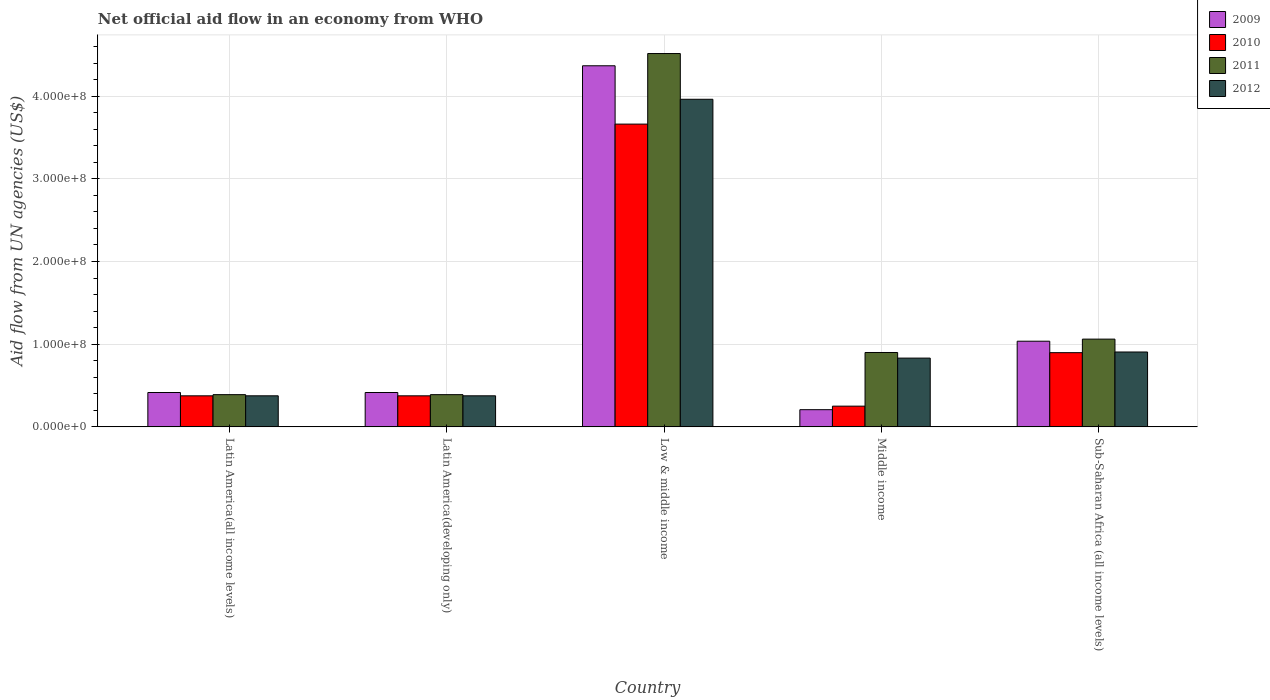How many different coloured bars are there?
Offer a very short reply. 4. How many groups of bars are there?
Your answer should be very brief. 5. Are the number of bars per tick equal to the number of legend labels?
Give a very brief answer. Yes. Are the number of bars on each tick of the X-axis equal?
Ensure brevity in your answer.  Yes. How many bars are there on the 2nd tick from the right?
Provide a succinct answer. 4. What is the label of the 3rd group of bars from the left?
Offer a very short reply. Low & middle income. In how many cases, is the number of bars for a given country not equal to the number of legend labels?
Give a very brief answer. 0. What is the net official aid flow in 2011 in Low & middle income?
Give a very brief answer. 4.52e+08. Across all countries, what is the maximum net official aid flow in 2011?
Offer a terse response. 4.52e+08. Across all countries, what is the minimum net official aid flow in 2010?
Ensure brevity in your answer.  2.51e+07. In which country was the net official aid flow in 2011 maximum?
Offer a very short reply. Low & middle income. In which country was the net official aid flow in 2012 minimum?
Offer a very short reply. Latin America(all income levels). What is the total net official aid flow in 2009 in the graph?
Ensure brevity in your answer.  6.44e+08. What is the difference between the net official aid flow in 2010 in Latin America(all income levels) and that in Latin America(developing only)?
Offer a very short reply. 0. What is the difference between the net official aid flow in 2012 in Middle income and the net official aid flow in 2011 in Low & middle income?
Keep it short and to the point. -3.68e+08. What is the average net official aid flow in 2010 per country?
Make the answer very short. 1.11e+08. What is the difference between the net official aid flow of/in 2009 and net official aid flow of/in 2010 in Low & middle income?
Make the answer very short. 7.06e+07. What is the ratio of the net official aid flow in 2009 in Latin America(all income levels) to that in Middle income?
Keep it short and to the point. 2. What is the difference between the highest and the second highest net official aid flow in 2012?
Your answer should be compact. 3.06e+08. What is the difference between the highest and the lowest net official aid flow in 2011?
Provide a short and direct response. 4.13e+08. In how many countries, is the net official aid flow in 2012 greater than the average net official aid flow in 2012 taken over all countries?
Make the answer very short. 1. Is the sum of the net official aid flow in 2010 in Latin America(all income levels) and Middle income greater than the maximum net official aid flow in 2011 across all countries?
Make the answer very short. No. Is it the case that in every country, the sum of the net official aid flow in 2012 and net official aid flow in 2011 is greater than the sum of net official aid flow in 2009 and net official aid flow in 2010?
Provide a short and direct response. No. What does the 4th bar from the right in Middle income represents?
Make the answer very short. 2009. Are all the bars in the graph horizontal?
Your response must be concise. No. How many countries are there in the graph?
Offer a very short reply. 5. What is the difference between two consecutive major ticks on the Y-axis?
Provide a succinct answer. 1.00e+08. Are the values on the major ticks of Y-axis written in scientific E-notation?
Your response must be concise. Yes. Does the graph contain grids?
Provide a short and direct response. Yes. Where does the legend appear in the graph?
Your response must be concise. Top right. What is the title of the graph?
Make the answer very short. Net official aid flow in an economy from WHO. Does "1999" appear as one of the legend labels in the graph?
Your response must be concise. No. What is the label or title of the X-axis?
Offer a very short reply. Country. What is the label or title of the Y-axis?
Offer a terse response. Aid flow from UN agencies (US$). What is the Aid flow from UN agencies (US$) in 2009 in Latin America(all income levels)?
Ensure brevity in your answer.  4.16e+07. What is the Aid flow from UN agencies (US$) of 2010 in Latin America(all income levels)?
Offer a terse response. 3.76e+07. What is the Aid flow from UN agencies (US$) in 2011 in Latin America(all income levels)?
Offer a very short reply. 3.90e+07. What is the Aid flow from UN agencies (US$) in 2012 in Latin America(all income levels)?
Keep it short and to the point. 3.76e+07. What is the Aid flow from UN agencies (US$) in 2009 in Latin America(developing only)?
Your response must be concise. 4.16e+07. What is the Aid flow from UN agencies (US$) of 2010 in Latin America(developing only)?
Provide a short and direct response. 3.76e+07. What is the Aid flow from UN agencies (US$) of 2011 in Latin America(developing only)?
Give a very brief answer. 3.90e+07. What is the Aid flow from UN agencies (US$) in 2012 in Latin America(developing only)?
Your response must be concise. 3.76e+07. What is the Aid flow from UN agencies (US$) in 2009 in Low & middle income?
Provide a succinct answer. 4.37e+08. What is the Aid flow from UN agencies (US$) of 2010 in Low & middle income?
Your response must be concise. 3.66e+08. What is the Aid flow from UN agencies (US$) of 2011 in Low & middle income?
Your answer should be very brief. 4.52e+08. What is the Aid flow from UN agencies (US$) in 2012 in Low & middle income?
Provide a short and direct response. 3.96e+08. What is the Aid flow from UN agencies (US$) of 2009 in Middle income?
Make the answer very short. 2.08e+07. What is the Aid flow from UN agencies (US$) in 2010 in Middle income?
Offer a very short reply. 2.51e+07. What is the Aid flow from UN agencies (US$) of 2011 in Middle income?
Your response must be concise. 9.00e+07. What is the Aid flow from UN agencies (US$) of 2012 in Middle income?
Your answer should be compact. 8.32e+07. What is the Aid flow from UN agencies (US$) in 2009 in Sub-Saharan Africa (all income levels)?
Offer a terse response. 1.04e+08. What is the Aid flow from UN agencies (US$) in 2010 in Sub-Saharan Africa (all income levels)?
Provide a succinct answer. 8.98e+07. What is the Aid flow from UN agencies (US$) of 2011 in Sub-Saharan Africa (all income levels)?
Give a very brief answer. 1.06e+08. What is the Aid flow from UN agencies (US$) in 2012 in Sub-Saharan Africa (all income levels)?
Give a very brief answer. 9.06e+07. Across all countries, what is the maximum Aid flow from UN agencies (US$) of 2009?
Provide a succinct answer. 4.37e+08. Across all countries, what is the maximum Aid flow from UN agencies (US$) of 2010?
Ensure brevity in your answer.  3.66e+08. Across all countries, what is the maximum Aid flow from UN agencies (US$) of 2011?
Your response must be concise. 4.52e+08. Across all countries, what is the maximum Aid flow from UN agencies (US$) in 2012?
Keep it short and to the point. 3.96e+08. Across all countries, what is the minimum Aid flow from UN agencies (US$) in 2009?
Your response must be concise. 2.08e+07. Across all countries, what is the minimum Aid flow from UN agencies (US$) of 2010?
Provide a succinct answer. 2.51e+07. Across all countries, what is the minimum Aid flow from UN agencies (US$) in 2011?
Your answer should be very brief. 3.90e+07. Across all countries, what is the minimum Aid flow from UN agencies (US$) in 2012?
Provide a succinct answer. 3.76e+07. What is the total Aid flow from UN agencies (US$) of 2009 in the graph?
Give a very brief answer. 6.44e+08. What is the total Aid flow from UN agencies (US$) in 2010 in the graph?
Provide a short and direct response. 5.56e+08. What is the total Aid flow from UN agencies (US$) in 2011 in the graph?
Your answer should be very brief. 7.26e+08. What is the total Aid flow from UN agencies (US$) in 2012 in the graph?
Make the answer very short. 6.45e+08. What is the difference between the Aid flow from UN agencies (US$) of 2011 in Latin America(all income levels) and that in Latin America(developing only)?
Ensure brevity in your answer.  0. What is the difference between the Aid flow from UN agencies (US$) of 2012 in Latin America(all income levels) and that in Latin America(developing only)?
Your answer should be very brief. 0. What is the difference between the Aid flow from UN agencies (US$) in 2009 in Latin America(all income levels) and that in Low & middle income?
Offer a very short reply. -3.95e+08. What is the difference between the Aid flow from UN agencies (US$) in 2010 in Latin America(all income levels) and that in Low & middle income?
Keep it short and to the point. -3.29e+08. What is the difference between the Aid flow from UN agencies (US$) in 2011 in Latin America(all income levels) and that in Low & middle income?
Provide a short and direct response. -4.13e+08. What is the difference between the Aid flow from UN agencies (US$) in 2012 in Latin America(all income levels) and that in Low & middle income?
Provide a succinct answer. -3.59e+08. What is the difference between the Aid flow from UN agencies (US$) of 2009 in Latin America(all income levels) and that in Middle income?
Ensure brevity in your answer.  2.08e+07. What is the difference between the Aid flow from UN agencies (US$) in 2010 in Latin America(all income levels) and that in Middle income?
Make the answer very short. 1.25e+07. What is the difference between the Aid flow from UN agencies (US$) in 2011 in Latin America(all income levels) and that in Middle income?
Offer a terse response. -5.10e+07. What is the difference between the Aid flow from UN agencies (US$) of 2012 in Latin America(all income levels) and that in Middle income?
Provide a succinct answer. -4.56e+07. What is the difference between the Aid flow from UN agencies (US$) in 2009 in Latin America(all income levels) and that in Sub-Saharan Africa (all income levels)?
Provide a short and direct response. -6.20e+07. What is the difference between the Aid flow from UN agencies (US$) in 2010 in Latin America(all income levels) and that in Sub-Saharan Africa (all income levels)?
Your answer should be very brief. -5.22e+07. What is the difference between the Aid flow from UN agencies (US$) in 2011 in Latin America(all income levels) and that in Sub-Saharan Africa (all income levels)?
Keep it short and to the point. -6.72e+07. What is the difference between the Aid flow from UN agencies (US$) of 2012 in Latin America(all income levels) and that in Sub-Saharan Africa (all income levels)?
Your answer should be very brief. -5.30e+07. What is the difference between the Aid flow from UN agencies (US$) of 2009 in Latin America(developing only) and that in Low & middle income?
Provide a short and direct response. -3.95e+08. What is the difference between the Aid flow from UN agencies (US$) in 2010 in Latin America(developing only) and that in Low & middle income?
Your response must be concise. -3.29e+08. What is the difference between the Aid flow from UN agencies (US$) of 2011 in Latin America(developing only) and that in Low & middle income?
Your answer should be compact. -4.13e+08. What is the difference between the Aid flow from UN agencies (US$) in 2012 in Latin America(developing only) and that in Low & middle income?
Your answer should be compact. -3.59e+08. What is the difference between the Aid flow from UN agencies (US$) in 2009 in Latin America(developing only) and that in Middle income?
Your answer should be compact. 2.08e+07. What is the difference between the Aid flow from UN agencies (US$) in 2010 in Latin America(developing only) and that in Middle income?
Your response must be concise. 1.25e+07. What is the difference between the Aid flow from UN agencies (US$) in 2011 in Latin America(developing only) and that in Middle income?
Keep it short and to the point. -5.10e+07. What is the difference between the Aid flow from UN agencies (US$) in 2012 in Latin America(developing only) and that in Middle income?
Offer a terse response. -4.56e+07. What is the difference between the Aid flow from UN agencies (US$) of 2009 in Latin America(developing only) and that in Sub-Saharan Africa (all income levels)?
Your response must be concise. -6.20e+07. What is the difference between the Aid flow from UN agencies (US$) of 2010 in Latin America(developing only) and that in Sub-Saharan Africa (all income levels)?
Ensure brevity in your answer.  -5.22e+07. What is the difference between the Aid flow from UN agencies (US$) in 2011 in Latin America(developing only) and that in Sub-Saharan Africa (all income levels)?
Provide a succinct answer. -6.72e+07. What is the difference between the Aid flow from UN agencies (US$) in 2012 in Latin America(developing only) and that in Sub-Saharan Africa (all income levels)?
Make the answer very short. -5.30e+07. What is the difference between the Aid flow from UN agencies (US$) in 2009 in Low & middle income and that in Middle income?
Your response must be concise. 4.16e+08. What is the difference between the Aid flow from UN agencies (US$) in 2010 in Low & middle income and that in Middle income?
Offer a terse response. 3.41e+08. What is the difference between the Aid flow from UN agencies (US$) of 2011 in Low & middle income and that in Middle income?
Give a very brief answer. 3.62e+08. What is the difference between the Aid flow from UN agencies (US$) in 2012 in Low & middle income and that in Middle income?
Your response must be concise. 3.13e+08. What is the difference between the Aid flow from UN agencies (US$) in 2009 in Low & middle income and that in Sub-Saharan Africa (all income levels)?
Provide a succinct answer. 3.33e+08. What is the difference between the Aid flow from UN agencies (US$) in 2010 in Low & middle income and that in Sub-Saharan Africa (all income levels)?
Provide a short and direct response. 2.76e+08. What is the difference between the Aid flow from UN agencies (US$) of 2011 in Low & middle income and that in Sub-Saharan Africa (all income levels)?
Give a very brief answer. 3.45e+08. What is the difference between the Aid flow from UN agencies (US$) in 2012 in Low & middle income and that in Sub-Saharan Africa (all income levels)?
Your response must be concise. 3.06e+08. What is the difference between the Aid flow from UN agencies (US$) of 2009 in Middle income and that in Sub-Saharan Africa (all income levels)?
Your answer should be compact. -8.28e+07. What is the difference between the Aid flow from UN agencies (US$) of 2010 in Middle income and that in Sub-Saharan Africa (all income levels)?
Your answer should be compact. -6.47e+07. What is the difference between the Aid flow from UN agencies (US$) of 2011 in Middle income and that in Sub-Saharan Africa (all income levels)?
Your response must be concise. -1.62e+07. What is the difference between the Aid flow from UN agencies (US$) of 2012 in Middle income and that in Sub-Saharan Africa (all income levels)?
Your answer should be compact. -7.39e+06. What is the difference between the Aid flow from UN agencies (US$) in 2009 in Latin America(all income levels) and the Aid flow from UN agencies (US$) in 2010 in Latin America(developing only)?
Give a very brief answer. 4.01e+06. What is the difference between the Aid flow from UN agencies (US$) of 2009 in Latin America(all income levels) and the Aid flow from UN agencies (US$) of 2011 in Latin America(developing only)?
Offer a terse response. 2.59e+06. What is the difference between the Aid flow from UN agencies (US$) of 2009 in Latin America(all income levels) and the Aid flow from UN agencies (US$) of 2012 in Latin America(developing only)?
Provide a succinct answer. 3.99e+06. What is the difference between the Aid flow from UN agencies (US$) of 2010 in Latin America(all income levels) and the Aid flow from UN agencies (US$) of 2011 in Latin America(developing only)?
Ensure brevity in your answer.  -1.42e+06. What is the difference between the Aid flow from UN agencies (US$) in 2011 in Latin America(all income levels) and the Aid flow from UN agencies (US$) in 2012 in Latin America(developing only)?
Make the answer very short. 1.40e+06. What is the difference between the Aid flow from UN agencies (US$) in 2009 in Latin America(all income levels) and the Aid flow from UN agencies (US$) in 2010 in Low & middle income?
Your response must be concise. -3.25e+08. What is the difference between the Aid flow from UN agencies (US$) in 2009 in Latin America(all income levels) and the Aid flow from UN agencies (US$) in 2011 in Low & middle income?
Provide a short and direct response. -4.10e+08. What is the difference between the Aid flow from UN agencies (US$) of 2009 in Latin America(all income levels) and the Aid flow from UN agencies (US$) of 2012 in Low & middle income?
Ensure brevity in your answer.  -3.55e+08. What is the difference between the Aid flow from UN agencies (US$) in 2010 in Latin America(all income levels) and the Aid flow from UN agencies (US$) in 2011 in Low & middle income?
Your answer should be compact. -4.14e+08. What is the difference between the Aid flow from UN agencies (US$) of 2010 in Latin America(all income levels) and the Aid flow from UN agencies (US$) of 2012 in Low & middle income?
Keep it short and to the point. -3.59e+08. What is the difference between the Aid flow from UN agencies (US$) of 2011 in Latin America(all income levels) and the Aid flow from UN agencies (US$) of 2012 in Low & middle income?
Offer a terse response. -3.57e+08. What is the difference between the Aid flow from UN agencies (US$) of 2009 in Latin America(all income levels) and the Aid flow from UN agencies (US$) of 2010 in Middle income?
Provide a succinct answer. 1.65e+07. What is the difference between the Aid flow from UN agencies (US$) of 2009 in Latin America(all income levels) and the Aid flow from UN agencies (US$) of 2011 in Middle income?
Provide a succinct answer. -4.84e+07. What is the difference between the Aid flow from UN agencies (US$) of 2009 in Latin America(all income levels) and the Aid flow from UN agencies (US$) of 2012 in Middle income?
Ensure brevity in your answer.  -4.16e+07. What is the difference between the Aid flow from UN agencies (US$) in 2010 in Latin America(all income levels) and the Aid flow from UN agencies (US$) in 2011 in Middle income?
Your answer should be compact. -5.24e+07. What is the difference between the Aid flow from UN agencies (US$) of 2010 in Latin America(all income levels) and the Aid flow from UN agencies (US$) of 2012 in Middle income?
Offer a terse response. -4.56e+07. What is the difference between the Aid flow from UN agencies (US$) of 2011 in Latin America(all income levels) and the Aid flow from UN agencies (US$) of 2012 in Middle income?
Your answer should be compact. -4.42e+07. What is the difference between the Aid flow from UN agencies (US$) of 2009 in Latin America(all income levels) and the Aid flow from UN agencies (US$) of 2010 in Sub-Saharan Africa (all income levels)?
Your answer should be compact. -4.82e+07. What is the difference between the Aid flow from UN agencies (US$) in 2009 in Latin America(all income levels) and the Aid flow from UN agencies (US$) in 2011 in Sub-Saharan Africa (all income levels)?
Make the answer very short. -6.46e+07. What is the difference between the Aid flow from UN agencies (US$) of 2009 in Latin America(all income levels) and the Aid flow from UN agencies (US$) of 2012 in Sub-Saharan Africa (all income levels)?
Provide a short and direct response. -4.90e+07. What is the difference between the Aid flow from UN agencies (US$) in 2010 in Latin America(all income levels) and the Aid flow from UN agencies (US$) in 2011 in Sub-Saharan Africa (all income levels)?
Make the answer very short. -6.86e+07. What is the difference between the Aid flow from UN agencies (US$) in 2010 in Latin America(all income levels) and the Aid flow from UN agencies (US$) in 2012 in Sub-Saharan Africa (all income levels)?
Give a very brief answer. -5.30e+07. What is the difference between the Aid flow from UN agencies (US$) in 2011 in Latin America(all income levels) and the Aid flow from UN agencies (US$) in 2012 in Sub-Saharan Africa (all income levels)?
Offer a terse response. -5.16e+07. What is the difference between the Aid flow from UN agencies (US$) of 2009 in Latin America(developing only) and the Aid flow from UN agencies (US$) of 2010 in Low & middle income?
Keep it short and to the point. -3.25e+08. What is the difference between the Aid flow from UN agencies (US$) of 2009 in Latin America(developing only) and the Aid flow from UN agencies (US$) of 2011 in Low & middle income?
Give a very brief answer. -4.10e+08. What is the difference between the Aid flow from UN agencies (US$) in 2009 in Latin America(developing only) and the Aid flow from UN agencies (US$) in 2012 in Low & middle income?
Provide a succinct answer. -3.55e+08. What is the difference between the Aid flow from UN agencies (US$) of 2010 in Latin America(developing only) and the Aid flow from UN agencies (US$) of 2011 in Low & middle income?
Your answer should be very brief. -4.14e+08. What is the difference between the Aid flow from UN agencies (US$) in 2010 in Latin America(developing only) and the Aid flow from UN agencies (US$) in 2012 in Low & middle income?
Provide a short and direct response. -3.59e+08. What is the difference between the Aid flow from UN agencies (US$) of 2011 in Latin America(developing only) and the Aid flow from UN agencies (US$) of 2012 in Low & middle income?
Offer a terse response. -3.57e+08. What is the difference between the Aid flow from UN agencies (US$) of 2009 in Latin America(developing only) and the Aid flow from UN agencies (US$) of 2010 in Middle income?
Your answer should be compact. 1.65e+07. What is the difference between the Aid flow from UN agencies (US$) in 2009 in Latin America(developing only) and the Aid flow from UN agencies (US$) in 2011 in Middle income?
Provide a succinct answer. -4.84e+07. What is the difference between the Aid flow from UN agencies (US$) of 2009 in Latin America(developing only) and the Aid flow from UN agencies (US$) of 2012 in Middle income?
Offer a terse response. -4.16e+07. What is the difference between the Aid flow from UN agencies (US$) of 2010 in Latin America(developing only) and the Aid flow from UN agencies (US$) of 2011 in Middle income?
Offer a very short reply. -5.24e+07. What is the difference between the Aid flow from UN agencies (US$) of 2010 in Latin America(developing only) and the Aid flow from UN agencies (US$) of 2012 in Middle income?
Your answer should be compact. -4.56e+07. What is the difference between the Aid flow from UN agencies (US$) of 2011 in Latin America(developing only) and the Aid flow from UN agencies (US$) of 2012 in Middle income?
Your answer should be very brief. -4.42e+07. What is the difference between the Aid flow from UN agencies (US$) of 2009 in Latin America(developing only) and the Aid flow from UN agencies (US$) of 2010 in Sub-Saharan Africa (all income levels)?
Provide a succinct answer. -4.82e+07. What is the difference between the Aid flow from UN agencies (US$) in 2009 in Latin America(developing only) and the Aid flow from UN agencies (US$) in 2011 in Sub-Saharan Africa (all income levels)?
Ensure brevity in your answer.  -6.46e+07. What is the difference between the Aid flow from UN agencies (US$) of 2009 in Latin America(developing only) and the Aid flow from UN agencies (US$) of 2012 in Sub-Saharan Africa (all income levels)?
Keep it short and to the point. -4.90e+07. What is the difference between the Aid flow from UN agencies (US$) of 2010 in Latin America(developing only) and the Aid flow from UN agencies (US$) of 2011 in Sub-Saharan Africa (all income levels)?
Make the answer very short. -6.86e+07. What is the difference between the Aid flow from UN agencies (US$) of 2010 in Latin America(developing only) and the Aid flow from UN agencies (US$) of 2012 in Sub-Saharan Africa (all income levels)?
Give a very brief answer. -5.30e+07. What is the difference between the Aid flow from UN agencies (US$) of 2011 in Latin America(developing only) and the Aid flow from UN agencies (US$) of 2012 in Sub-Saharan Africa (all income levels)?
Provide a short and direct response. -5.16e+07. What is the difference between the Aid flow from UN agencies (US$) of 2009 in Low & middle income and the Aid flow from UN agencies (US$) of 2010 in Middle income?
Provide a succinct answer. 4.12e+08. What is the difference between the Aid flow from UN agencies (US$) in 2009 in Low & middle income and the Aid flow from UN agencies (US$) in 2011 in Middle income?
Keep it short and to the point. 3.47e+08. What is the difference between the Aid flow from UN agencies (US$) in 2009 in Low & middle income and the Aid flow from UN agencies (US$) in 2012 in Middle income?
Offer a very short reply. 3.54e+08. What is the difference between the Aid flow from UN agencies (US$) in 2010 in Low & middle income and the Aid flow from UN agencies (US$) in 2011 in Middle income?
Offer a terse response. 2.76e+08. What is the difference between the Aid flow from UN agencies (US$) in 2010 in Low & middle income and the Aid flow from UN agencies (US$) in 2012 in Middle income?
Your response must be concise. 2.83e+08. What is the difference between the Aid flow from UN agencies (US$) of 2011 in Low & middle income and the Aid flow from UN agencies (US$) of 2012 in Middle income?
Make the answer very short. 3.68e+08. What is the difference between the Aid flow from UN agencies (US$) in 2009 in Low & middle income and the Aid flow from UN agencies (US$) in 2010 in Sub-Saharan Africa (all income levels)?
Your answer should be compact. 3.47e+08. What is the difference between the Aid flow from UN agencies (US$) in 2009 in Low & middle income and the Aid flow from UN agencies (US$) in 2011 in Sub-Saharan Africa (all income levels)?
Give a very brief answer. 3.31e+08. What is the difference between the Aid flow from UN agencies (US$) in 2009 in Low & middle income and the Aid flow from UN agencies (US$) in 2012 in Sub-Saharan Africa (all income levels)?
Make the answer very short. 3.46e+08. What is the difference between the Aid flow from UN agencies (US$) in 2010 in Low & middle income and the Aid flow from UN agencies (US$) in 2011 in Sub-Saharan Africa (all income levels)?
Provide a short and direct response. 2.60e+08. What is the difference between the Aid flow from UN agencies (US$) of 2010 in Low & middle income and the Aid flow from UN agencies (US$) of 2012 in Sub-Saharan Africa (all income levels)?
Provide a short and direct response. 2.76e+08. What is the difference between the Aid flow from UN agencies (US$) in 2011 in Low & middle income and the Aid flow from UN agencies (US$) in 2012 in Sub-Saharan Africa (all income levels)?
Your answer should be compact. 3.61e+08. What is the difference between the Aid flow from UN agencies (US$) of 2009 in Middle income and the Aid flow from UN agencies (US$) of 2010 in Sub-Saharan Africa (all income levels)?
Ensure brevity in your answer.  -6.90e+07. What is the difference between the Aid flow from UN agencies (US$) in 2009 in Middle income and the Aid flow from UN agencies (US$) in 2011 in Sub-Saharan Africa (all income levels)?
Provide a succinct answer. -8.54e+07. What is the difference between the Aid flow from UN agencies (US$) of 2009 in Middle income and the Aid flow from UN agencies (US$) of 2012 in Sub-Saharan Africa (all income levels)?
Provide a short and direct response. -6.98e+07. What is the difference between the Aid flow from UN agencies (US$) in 2010 in Middle income and the Aid flow from UN agencies (US$) in 2011 in Sub-Saharan Africa (all income levels)?
Keep it short and to the point. -8.11e+07. What is the difference between the Aid flow from UN agencies (US$) of 2010 in Middle income and the Aid flow from UN agencies (US$) of 2012 in Sub-Saharan Africa (all income levels)?
Ensure brevity in your answer.  -6.55e+07. What is the difference between the Aid flow from UN agencies (US$) in 2011 in Middle income and the Aid flow from UN agencies (US$) in 2012 in Sub-Saharan Africa (all income levels)?
Make the answer very short. -5.90e+05. What is the average Aid flow from UN agencies (US$) of 2009 per country?
Offer a terse response. 1.29e+08. What is the average Aid flow from UN agencies (US$) of 2010 per country?
Offer a very short reply. 1.11e+08. What is the average Aid flow from UN agencies (US$) in 2011 per country?
Make the answer very short. 1.45e+08. What is the average Aid flow from UN agencies (US$) in 2012 per country?
Provide a succinct answer. 1.29e+08. What is the difference between the Aid flow from UN agencies (US$) of 2009 and Aid flow from UN agencies (US$) of 2010 in Latin America(all income levels)?
Ensure brevity in your answer.  4.01e+06. What is the difference between the Aid flow from UN agencies (US$) in 2009 and Aid flow from UN agencies (US$) in 2011 in Latin America(all income levels)?
Ensure brevity in your answer.  2.59e+06. What is the difference between the Aid flow from UN agencies (US$) in 2009 and Aid flow from UN agencies (US$) in 2012 in Latin America(all income levels)?
Give a very brief answer. 3.99e+06. What is the difference between the Aid flow from UN agencies (US$) of 2010 and Aid flow from UN agencies (US$) of 2011 in Latin America(all income levels)?
Ensure brevity in your answer.  -1.42e+06. What is the difference between the Aid flow from UN agencies (US$) of 2011 and Aid flow from UN agencies (US$) of 2012 in Latin America(all income levels)?
Provide a succinct answer. 1.40e+06. What is the difference between the Aid flow from UN agencies (US$) of 2009 and Aid flow from UN agencies (US$) of 2010 in Latin America(developing only)?
Your answer should be compact. 4.01e+06. What is the difference between the Aid flow from UN agencies (US$) of 2009 and Aid flow from UN agencies (US$) of 2011 in Latin America(developing only)?
Your answer should be compact. 2.59e+06. What is the difference between the Aid flow from UN agencies (US$) in 2009 and Aid flow from UN agencies (US$) in 2012 in Latin America(developing only)?
Offer a very short reply. 3.99e+06. What is the difference between the Aid flow from UN agencies (US$) in 2010 and Aid flow from UN agencies (US$) in 2011 in Latin America(developing only)?
Make the answer very short. -1.42e+06. What is the difference between the Aid flow from UN agencies (US$) in 2010 and Aid flow from UN agencies (US$) in 2012 in Latin America(developing only)?
Your response must be concise. -2.00e+04. What is the difference between the Aid flow from UN agencies (US$) in 2011 and Aid flow from UN agencies (US$) in 2012 in Latin America(developing only)?
Your response must be concise. 1.40e+06. What is the difference between the Aid flow from UN agencies (US$) of 2009 and Aid flow from UN agencies (US$) of 2010 in Low & middle income?
Provide a short and direct response. 7.06e+07. What is the difference between the Aid flow from UN agencies (US$) in 2009 and Aid flow from UN agencies (US$) in 2011 in Low & middle income?
Provide a short and direct response. -1.48e+07. What is the difference between the Aid flow from UN agencies (US$) of 2009 and Aid flow from UN agencies (US$) of 2012 in Low & middle income?
Offer a very short reply. 4.05e+07. What is the difference between the Aid flow from UN agencies (US$) of 2010 and Aid flow from UN agencies (US$) of 2011 in Low & middle income?
Provide a short and direct response. -8.54e+07. What is the difference between the Aid flow from UN agencies (US$) of 2010 and Aid flow from UN agencies (US$) of 2012 in Low & middle income?
Make the answer very short. -3.00e+07. What is the difference between the Aid flow from UN agencies (US$) in 2011 and Aid flow from UN agencies (US$) in 2012 in Low & middle income?
Make the answer very short. 5.53e+07. What is the difference between the Aid flow from UN agencies (US$) of 2009 and Aid flow from UN agencies (US$) of 2010 in Middle income?
Your answer should be compact. -4.27e+06. What is the difference between the Aid flow from UN agencies (US$) of 2009 and Aid flow from UN agencies (US$) of 2011 in Middle income?
Offer a very short reply. -6.92e+07. What is the difference between the Aid flow from UN agencies (US$) in 2009 and Aid flow from UN agencies (US$) in 2012 in Middle income?
Offer a terse response. -6.24e+07. What is the difference between the Aid flow from UN agencies (US$) of 2010 and Aid flow from UN agencies (US$) of 2011 in Middle income?
Provide a succinct answer. -6.49e+07. What is the difference between the Aid flow from UN agencies (US$) of 2010 and Aid flow from UN agencies (US$) of 2012 in Middle income?
Give a very brief answer. -5.81e+07. What is the difference between the Aid flow from UN agencies (US$) in 2011 and Aid flow from UN agencies (US$) in 2012 in Middle income?
Your answer should be very brief. 6.80e+06. What is the difference between the Aid flow from UN agencies (US$) in 2009 and Aid flow from UN agencies (US$) in 2010 in Sub-Saharan Africa (all income levels)?
Ensure brevity in your answer.  1.39e+07. What is the difference between the Aid flow from UN agencies (US$) of 2009 and Aid flow from UN agencies (US$) of 2011 in Sub-Saharan Africa (all income levels)?
Ensure brevity in your answer.  -2.53e+06. What is the difference between the Aid flow from UN agencies (US$) in 2009 and Aid flow from UN agencies (US$) in 2012 in Sub-Saharan Africa (all income levels)?
Give a very brief answer. 1.30e+07. What is the difference between the Aid flow from UN agencies (US$) in 2010 and Aid flow from UN agencies (US$) in 2011 in Sub-Saharan Africa (all income levels)?
Give a very brief answer. -1.64e+07. What is the difference between the Aid flow from UN agencies (US$) of 2010 and Aid flow from UN agencies (US$) of 2012 in Sub-Saharan Africa (all income levels)?
Keep it short and to the point. -8.10e+05. What is the difference between the Aid flow from UN agencies (US$) of 2011 and Aid flow from UN agencies (US$) of 2012 in Sub-Saharan Africa (all income levels)?
Give a very brief answer. 1.56e+07. What is the ratio of the Aid flow from UN agencies (US$) in 2009 in Latin America(all income levels) to that in Latin America(developing only)?
Your answer should be very brief. 1. What is the ratio of the Aid flow from UN agencies (US$) in 2011 in Latin America(all income levels) to that in Latin America(developing only)?
Keep it short and to the point. 1. What is the ratio of the Aid flow from UN agencies (US$) in 2012 in Latin America(all income levels) to that in Latin America(developing only)?
Your answer should be compact. 1. What is the ratio of the Aid flow from UN agencies (US$) of 2009 in Latin America(all income levels) to that in Low & middle income?
Your answer should be very brief. 0.1. What is the ratio of the Aid flow from UN agencies (US$) in 2010 in Latin America(all income levels) to that in Low & middle income?
Your response must be concise. 0.1. What is the ratio of the Aid flow from UN agencies (US$) in 2011 in Latin America(all income levels) to that in Low & middle income?
Give a very brief answer. 0.09. What is the ratio of the Aid flow from UN agencies (US$) of 2012 in Latin America(all income levels) to that in Low & middle income?
Make the answer very short. 0.09. What is the ratio of the Aid flow from UN agencies (US$) in 2009 in Latin America(all income levels) to that in Middle income?
Keep it short and to the point. 2. What is the ratio of the Aid flow from UN agencies (US$) in 2010 in Latin America(all income levels) to that in Middle income?
Provide a short and direct response. 1.5. What is the ratio of the Aid flow from UN agencies (US$) of 2011 in Latin America(all income levels) to that in Middle income?
Offer a terse response. 0.43. What is the ratio of the Aid flow from UN agencies (US$) in 2012 in Latin America(all income levels) to that in Middle income?
Your answer should be compact. 0.45. What is the ratio of the Aid flow from UN agencies (US$) in 2009 in Latin America(all income levels) to that in Sub-Saharan Africa (all income levels)?
Provide a short and direct response. 0.4. What is the ratio of the Aid flow from UN agencies (US$) of 2010 in Latin America(all income levels) to that in Sub-Saharan Africa (all income levels)?
Your answer should be very brief. 0.42. What is the ratio of the Aid flow from UN agencies (US$) of 2011 in Latin America(all income levels) to that in Sub-Saharan Africa (all income levels)?
Keep it short and to the point. 0.37. What is the ratio of the Aid flow from UN agencies (US$) of 2012 in Latin America(all income levels) to that in Sub-Saharan Africa (all income levels)?
Ensure brevity in your answer.  0.41. What is the ratio of the Aid flow from UN agencies (US$) in 2009 in Latin America(developing only) to that in Low & middle income?
Your response must be concise. 0.1. What is the ratio of the Aid flow from UN agencies (US$) of 2010 in Latin America(developing only) to that in Low & middle income?
Ensure brevity in your answer.  0.1. What is the ratio of the Aid flow from UN agencies (US$) of 2011 in Latin America(developing only) to that in Low & middle income?
Offer a very short reply. 0.09. What is the ratio of the Aid flow from UN agencies (US$) in 2012 in Latin America(developing only) to that in Low & middle income?
Provide a succinct answer. 0.09. What is the ratio of the Aid flow from UN agencies (US$) in 2009 in Latin America(developing only) to that in Middle income?
Keep it short and to the point. 2. What is the ratio of the Aid flow from UN agencies (US$) of 2010 in Latin America(developing only) to that in Middle income?
Offer a very short reply. 1.5. What is the ratio of the Aid flow from UN agencies (US$) of 2011 in Latin America(developing only) to that in Middle income?
Make the answer very short. 0.43. What is the ratio of the Aid flow from UN agencies (US$) of 2012 in Latin America(developing only) to that in Middle income?
Your response must be concise. 0.45. What is the ratio of the Aid flow from UN agencies (US$) of 2009 in Latin America(developing only) to that in Sub-Saharan Africa (all income levels)?
Make the answer very short. 0.4. What is the ratio of the Aid flow from UN agencies (US$) of 2010 in Latin America(developing only) to that in Sub-Saharan Africa (all income levels)?
Ensure brevity in your answer.  0.42. What is the ratio of the Aid flow from UN agencies (US$) in 2011 in Latin America(developing only) to that in Sub-Saharan Africa (all income levels)?
Ensure brevity in your answer.  0.37. What is the ratio of the Aid flow from UN agencies (US$) of 2012 in Latin America(developing only) to that in Sub-Saharan Africa (all income levels)?
Offer a terse response. 0.41. What is the ratio of the Aid flow from UN agencies (US$) of 2009 in Low & middle income to that in Middle income?
Your answer should be compact. 21. What is the ratio of the Aid flow from UN agencies (US$) of 2010 in Low & middle income to that in Middle income?
Keep it short and to the point. 14.61. What is the ratio of the Aid flow from UN agencies (US$) in 2011 in Low & middle income to that in Middle income?
Ensure brevity in your answer.  5.02. What is the ratio of the Aid flow from UN agencies (US$) in 2012 in Low & middle income to that in Middle income?
Your answer should be compact. 4.76. What is the ratio of the Aid flow from UN agencies (US$) in 2009 in Low & middle income to that in Sub-Saharan Africa (all income levels)?
Keep it short and to the point. 4.22. What is the ratio of the Aid flow from UN agencies (US$) in 2010 in Low & middle income to that in Sub-Saharan Africa (all income levels)?
Your answer should be compact. 4.08. What is the ratio of the Aid flow from UN agencies (US$) of 2011 in Low & middle income to that in Sub-Saharan Africa (all income levels)?
Offer a terse response. 4.25. What is the ratio of the Aid flow from UN agencies (US$) of 2012 in Low & middle income to that in Sub-Saharan Africa (all income levels)?
Give a very brief answer. 4.38. What is the ratio of the Aid flow from UN agencies (US$) of 2009 in Middle income to that in Sub-Saharan Africa (all income levels)?
Make the answer very short. 0.2. What is the ratio of the Aid flow from UN agencies (US$) in 2010 in Middle income to that in Sub-Saharan Africa (all income levels)?
Provide a short and direct response. 0.28. What is the ratio of the Aid flow from UN agencies (US$) in 2011 in Middle income to that in Sub-Saharan Africa (all income levels)?
Offer a very short reply. 0.85. What is the ratio of the Aid flow from UN agencies (US$) of 2012 in Middle income to that in Sub-Saharan Africa (all income levels)?
Ensure brevity in your answer.  0.92. What is the difference between the highest and the second highest Aid flow from UN agencies (US$) in 2009?
Your answer should be very brief. 3.33e+08. What is the difference between the highest and the second highest Aid flow from UN agencies (US$) in 2010?
Provide a short and direct response. 2.76e+08. What is the difference between the highest and the second highest Aid flow from UN agencies (US$) of 2011?
Give a very brief answer. 3.45e+08. What is the difference between the highest and the second highest Aid flow from UN agencies (US$) of 2012?
Ensure brevity in your answer.  3.06e+08. What is the difference between the highest and the lowest Aid flow from UN agencies (US$) of 2009?
Keep it short and to the point. 4.16e+08. What is the difference between the highest and the lowest Aid flow from UN agencies (US$) in 2010?
Your answer should be very brief. 3.41e+08. What is the difference between the highest and the lowest Aid flow from UN agencies (US$) in 2011?
Your answer should be very brief. 4.13e+08. What is the difference between the highest and the lowest Aid flow from UN agencies (US$) of 2012?
Your response must be concise. 3.59e+08. 